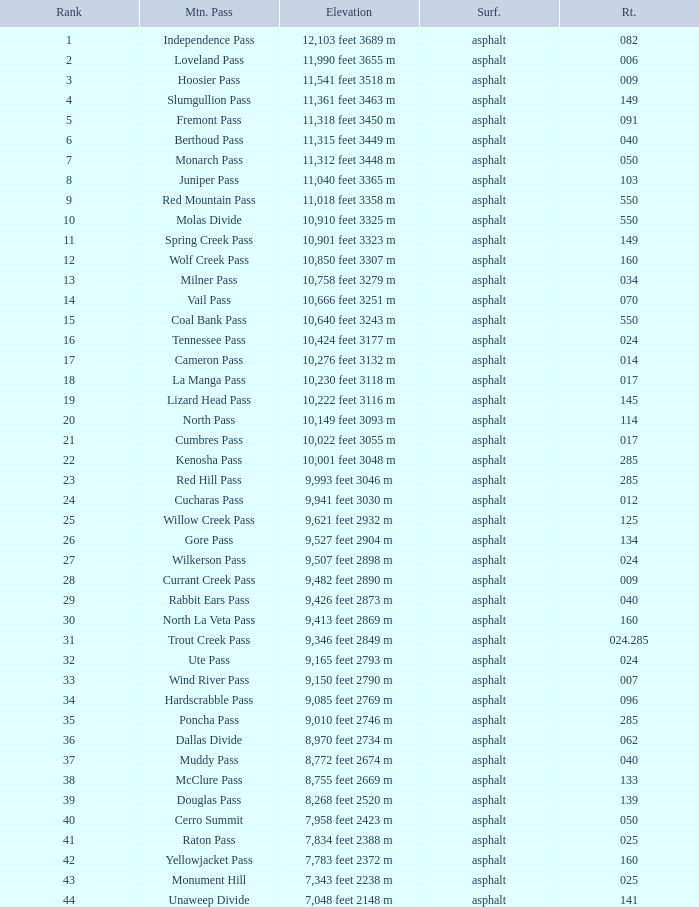What Mountain Pass has an Elevation of 10,001 feet 3048 m? Kenosha Pass. 